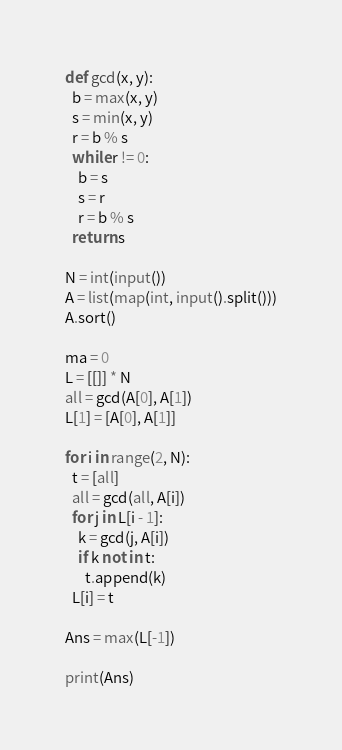<code> <loc_0><loc_0><loc_500><loc_500><_Python_>def gcd(x, y):
  b = max(x, y)
  s = min(x, y)
  r = b % s
  while r != 0:
    b = s
    s = r
    r = b % s
  return s

N = int(input())
A = list(map(int, input().split()))
A.sort()

ma = 0
L = [[]] * N
all = gcd(A[0], A[1])
L[1] = [A[0], A[1]]

for i in range(2, N):
  t = [all]
  all = gcd(all, A[i])
  for j in L[i - 1]:
    k = gcd(j, A[i])
    if k not in t:
      t.append(k)
  L[i] = t

Ans = max(L[-1])

print(Ans)</code> 